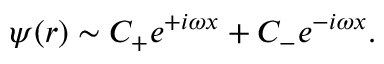Convert formula to latex. <formula><loc_0><loc_0><loc_500><loc_500>\psi ( r ) \sim C _ { + } e ^ { + i \omega x } + C _ { - } e ^ { - i \omega x } .</formula> 